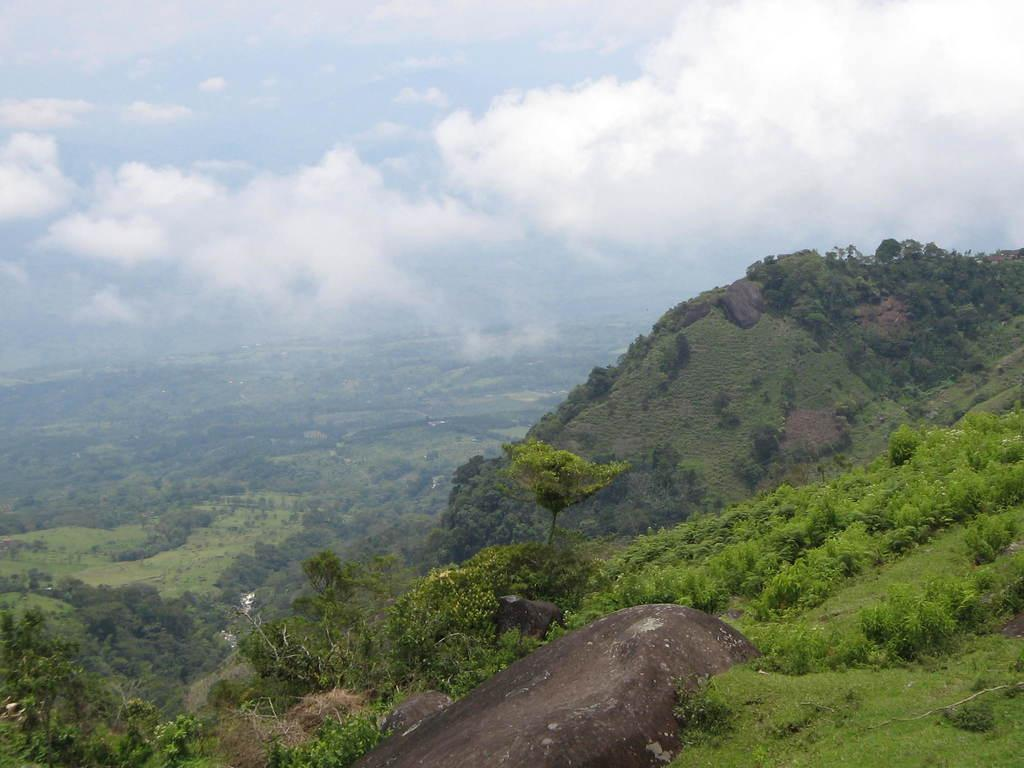What type of natural elements can be seen in the image? There are rocks, plants, and grass visible in the image. What can be seen in the background of the image? There are trees, clouds, and the sky visible in the background of the image. What type of vegetation is present on the surface at the bottom of the image? There is grass on the surface at the bottom of the image. What type of plastic objects can be seen in the image? There are no plastic objects present in the image. Is this image taken in a garden? The provided facts do not mention the location or setting of the image, so it cannot be determined if it is taken in a garden. 